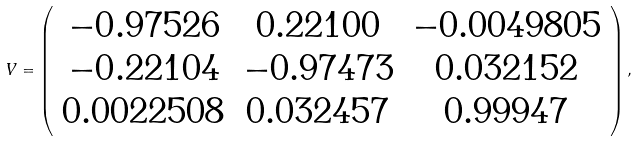Convert formula to latex. <formula><loc_0><loc_0><loc_500><loc_500>V = \left ( \begin{array} { c c c } { - 0 . 9 7 5 2 6 } & { 0 . 2 2 1 0 0 } & { - 0 . 0 0 4 9 8 0 5 } \\ { - 0 . 2 2 1 0 4 } & { - 0 . 9 7 4 7 3 } & { 0 . 0 3 2 1 5 2 } \\ { 0 . 0 0 2 2 5 0 8 } & { 0 . 0 3 2 4 5 7 } & { 0 . 9 9 9 4 7 } \end{array} \right ) ,</formula> 